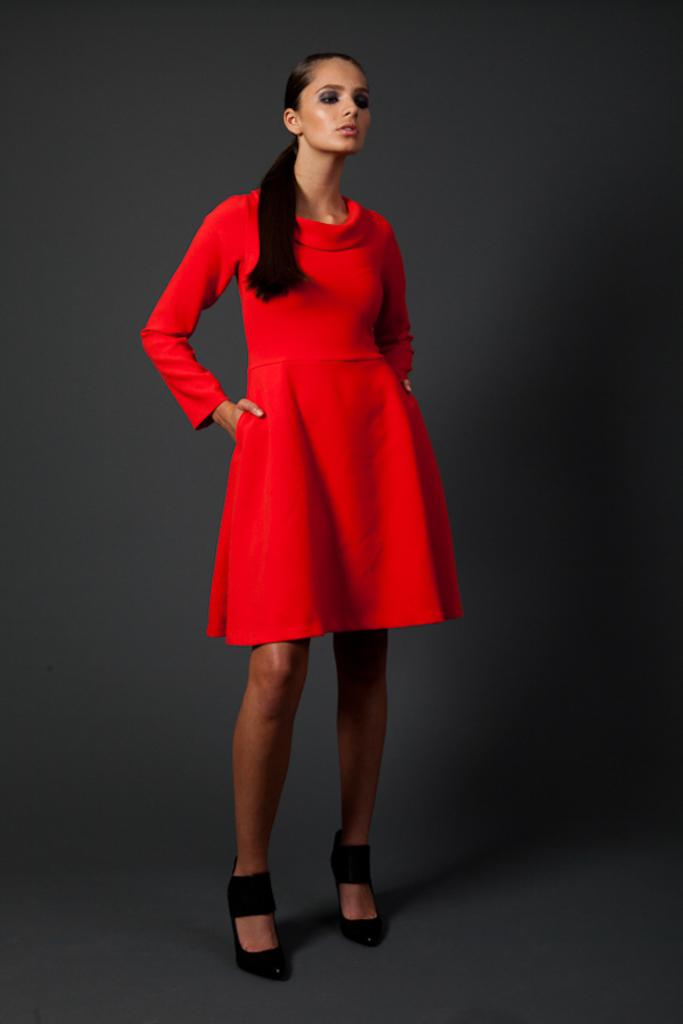What is the main subject of the image? The main subject of the image is a woman. What is the woman wearing on her feet? The woman is wearing black heels. What color is the dress the woman is wearing? The woman is wearing a red dress. What is the woman doing with her hands in the image? The woman has her hands on her hips. What type of approval is the woman seeking in the image? There is no indication in the image that the woman is seeking any approval. What items are on the list that the woman is holding in the image? There is no list present in the image. 